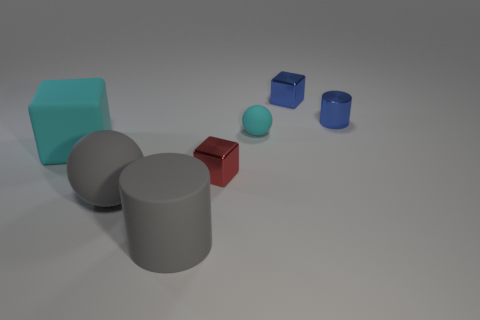What number of cylinders are both in front of the tiny blue cylinder and behind the large matte cylinder?
Your response must be concise. 0. Does the big cyan block have the same material as the tiny blue cylinder behind the big block?
Your answer should be compact. No. Is the number of gray rubber cylinders that are to the left of the big cyan rubber thing the same as the number of small blue shiny blocks?
Your answer should be very brief. No. The sphere that is to the right of the gray cylinder is what color?
Make the answer very short. Cyan. What number of other objects are the same color as the big ball?
Your response must be concise. 1. Is there any other thing that is the same size as the blue cylinder?
Provide a short and direct response. Yes. There is a cylinder right of the gray rubber cylinder; is it the same size as the cyan matte cube?
Your answer should be very brief. No. There is a gray object behind the big gray rubber cylinder; what material is it?
Ensure brevity in your answer.  Rubber. Are there any other things that are the same shape as the tiny red metal object?
Your answer should be very brief. Yes. What number of metallic objects are big gray spheres or tiny yellow cylinders?
Provide a short and direct response. 0. 